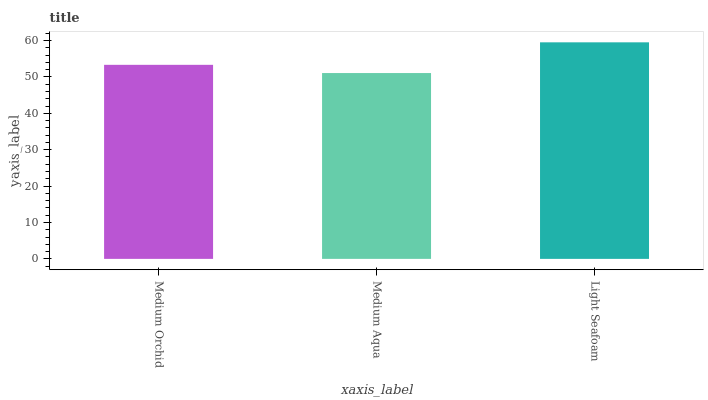Is Medium Aqua the minimum?
Answer yes or no. Yes. Is Light Seafoam the maximum?
Answer yes or no. Yes. Is Light Seafoam the minimum?
Answer yes or no. No. Is Medium Aqua the maximum?
Answer yes or no. No. Is Light Seafoam greater than Medium Aqua?
Answer yes or no. Yes. Is Medium Aqua less than Light Seafoam?
Answer yes or no. Yes. Is Medium Aqua greater than Light Seafoam?
Answer yes or no. No. Is Light Seafoam less than Medium Aqua?
Answer yes or no. No. Is Medium Orchid the high median?
Answer yes or no. Yes. Is Medium Orchid the low median?
Answer yes or no. Yes. Is Light Seafoam the high median?
Answer yes or no. No. Is Medium Aqua the low median?
Answer yes or no. No. 